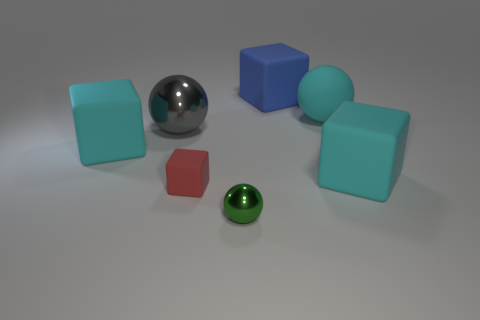What color is the rubber object that is left of the tiny red cube?
Your response must be concise. Cyan. There is a tiny thing to the right of the tiny rubber cube; what number of gray balls are in front of it?
Make the answer very short. 0. There is a blue object; is its size the same as the cyan rubber cube right of the small green metal object?
Keep it short and to the point. Yes. Are there any green balls that have the same size as the red block?
Your response must be concise. Yes. How many objects are either big gray spheres or small green shiny spheres?
Keep it short and to the point. 2. There is a cyan block that is to the right of the small green sphere; is it the same size as the cyan block that is left of the small green metal object?
Give a very brief answer. Yes. Are there any other rubber things of the same shape as the tiny red thing?
Ensure brevity in your answer.  Yes. Is the number of cyan blocks that are behind the big shiny object less than the number of cyan things?
Keep it short and to the point. Yes. Is the shape of the small green metal thing the same as the big gray metal object?
Give a very brief answer. Yes. What is the size of the cube to the left of the gray shiny object?
Provide a short and direct response. Large. 